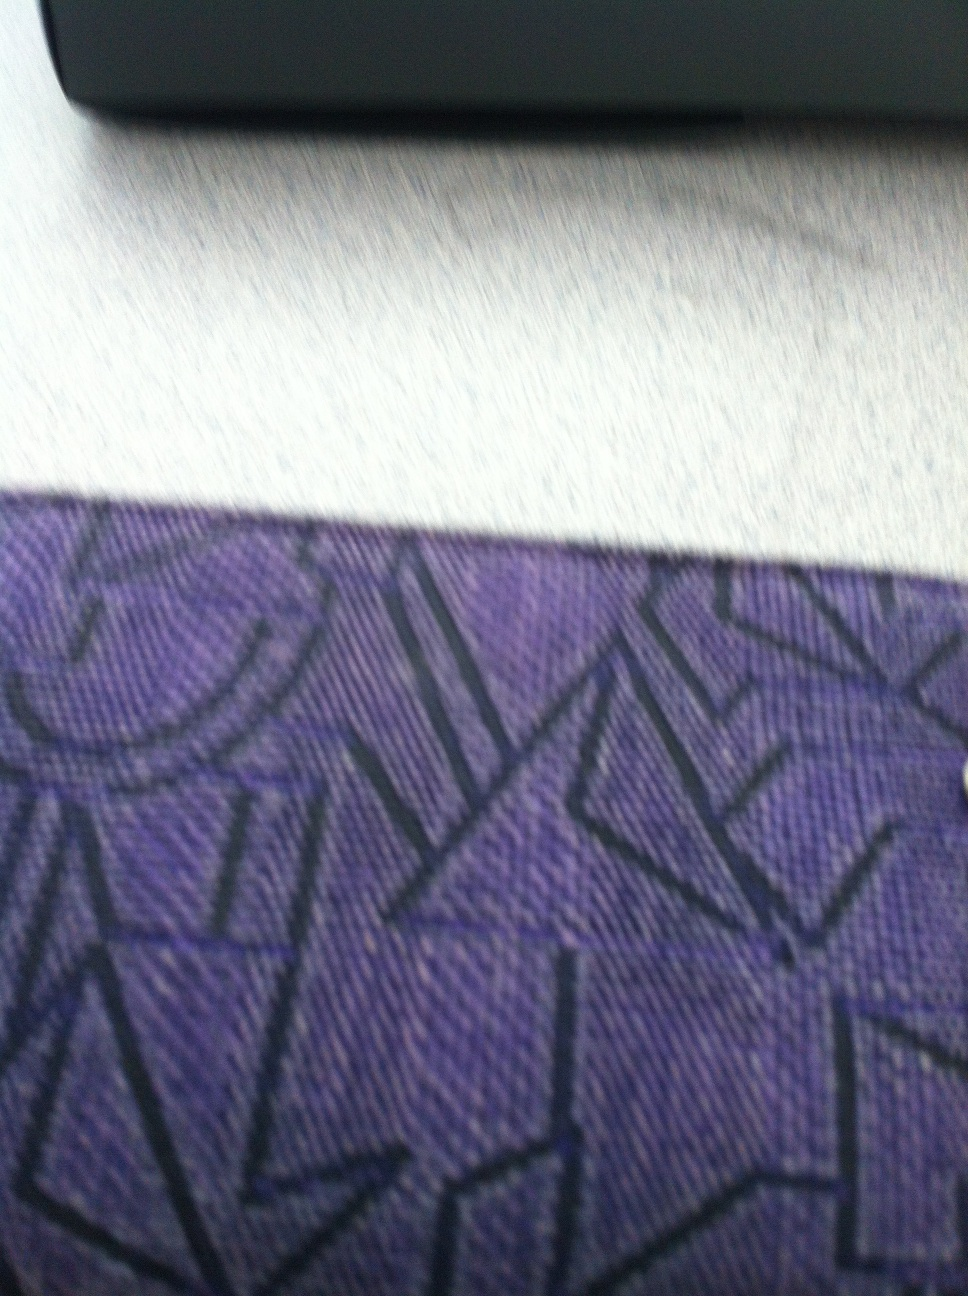Create a poem inspired by the design and colors of my wallet. In hues of purple deep and bold,
A story of design unfolds.
Geometric lines, a patterned grace,
In fabric’s weave, an artful trace.
Through travels vast, in hands it’s lain,
A wallet’s tale in purple’s reign.
Secrets whispered, dreams untold,
In every seam, a memory hold.
As days go by and nights grow cold,
The wallet’s stories quietly mold,
In colors rich and patterns wise,
A piece of art, beneath our eyes. 